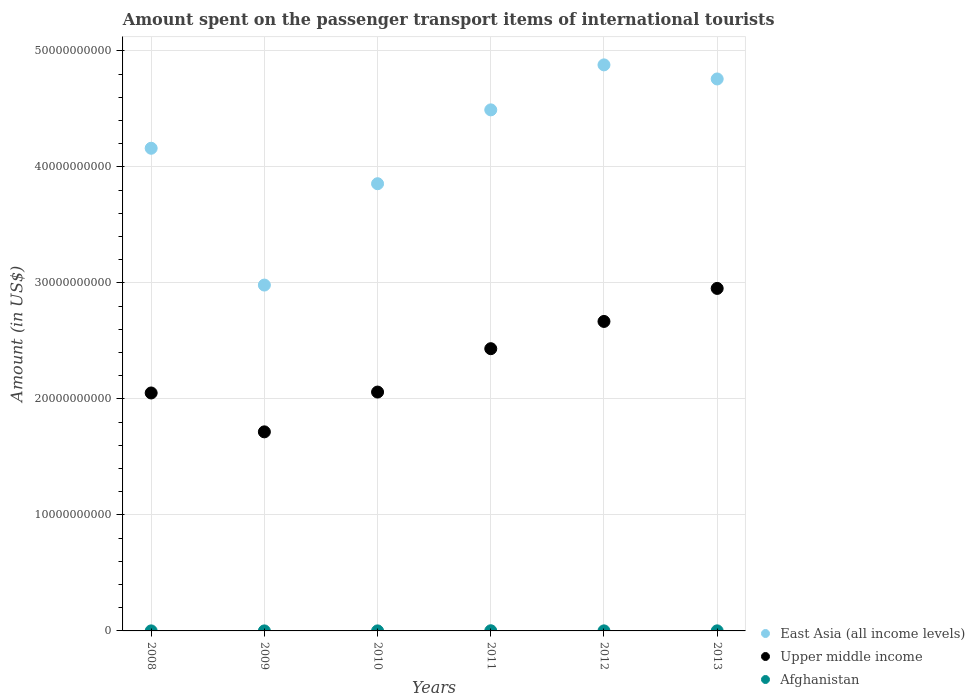How many different coloured dotlines are there?
Keep it short and to the point. 3. What is the amount spent on the passenger transport items of international tourists in Upper middle income in 2013?
Offer a terse response. 2.95e+1. Across all years, what is the maximum amount spent on the passenger transport items of international tourists in Afghanistan?
Ensure brevity in your answer.  1.40e+07. Across all years, what is the minimum amount spent on the passenger transport items of international tourists in Upper middle income?
Provide a short and direct response. 1.72e+1. What is the total amount spent on the passenger transport items of international tourists in Afghanistan in the graph?
Make the answer very short. 3.30e+07. What is the difference between the amount spent on the passenger transport items of international tourists in Afghanistan in 2011 and that in 2012?
Make the answer very short. 9.00e+06. What is the difference between the amount spent on the passenger transport items of international tourists in East Asia (all income levels) in 2011 and the amount spent on the passenger transport items of international tourists in Upper middle income in 2012?
Offer a terse response. 1.82e+1. What is the average amount spent on the passenger transport items of international tourists in Upper middle income per year?
Your answer should be compact. 2.31e+1. In the year 2011, what is the difference between the amount spent on the passenger transport items of international tourists in Afghanistan and amount spent on the passenger transport items of international tourists in Upper middle income?
Offer a terse response. -2.43e+1. In how many years, is the amount spent on the passenger transport items of international tourists in Afghanistan greater than 14000000000 US$?
Keep it short and to the point. 0. What is the ratio of the amount spent on the passenger transport items of international tourists in Afghanistan in 2012 to that in 2013?
Offer a very short reply. 0.83. Is the amount spent on the passenger transport items of international tourists in Afghanistan in 2008 less than that in 2010?
Your answer should be very brief. No. What is the difference between the highest and the lowest amount spent on the passenger transport items of international tourists in East Asia (all income levels)?
Your response must be concise. 1.90e+1. Is it the case that in every year, the sum of the amount spent on the passenger transport items of international tourists in Afghanistan and amount spent on the passenger transport items of international tourists in East Asia (all income levels)  is greater than the amount spent on the passenger transport items of international tourists in Upper middle income?
Your answer should be compact. Yes. Is the amount spent on the passenger transport items of international tourists in East Asia (all income levels) strictly less than the amount spent on the passenger transport items of international tourists in Afghanistan over the years?
Keep it short and to the point. No. How many dotlines are there?
Offer a very short reply. 3. What is the difference between two consecutive major ticks on the Y-axis?
Your response must be concise. 1.00e+1. Does the graph contain grids?
Keep it short and to the point. Yes. How are the legend labels stacked?
Offer a terse response. Vertical. What is the title of the graph?
Give a very brief answer. Amount spent on the passenger transport items of international tourists. What is the label or title of the X-axis?
Your answer should be compact. Years. What is the Amount (in US$) in East Asia (all income levels) in 2008?
Offer a terse response. 4.16e+1. What is the Amount (in US$) in Upper middle income in 2008?
Ensure brevity in your answer.  2.05e+1. What is the Amount (in US$) in Afghanistan in 2008?
Your answer should be compact. 3.00e+06. What is the Amount (in US$) of East Asia (all income levels) in 2009?
Your answer should be very brief. 2.98e+1. What is the Amount (in US$) in Upper middle income in 2009?
Ensure brevity in your answer.  1.72e+1. What is the Amount (in US$) of East Asia (all income levels) in 2010?
Your answer should be very brief. 3.86e+1. What is the Amount (in US$) of Upper middle income in 2010?
Your response must be concise. 2.06e+1. What is the Amount (in US$) of Afghanistan in 2010?
Provide a short and direct response. 3.00e+06. What is the Amount (in US$) of East Asia (all income levels) in 2011?
Provide a succinct answer. 4.49e+1. What is the Amount (in US$) in Upper middle income in 2011?
Give a very brief answer. 2.43e+1. What is the Amount (in US$) in Afghanistan in 2011?
Provide a succinct answer. 1.40e+07. What is the Amount (in US$) in East Asia (all income levels) in 2012?
Your answer should be compact. 4.88e+1. What is the Amount (in US$) of Upper middle income in 2012?
Make the answer very short. 2.67e+1. What is the Amount (in US$) in Afghanistan in 2012?
Offer a very short reply. 5.00e+06. What is the Amount (in US$) in East Asia (all income levels) in 2013?
Your answer should be compact. 4.76e+1. What is the Amount (in US$) in Upper middle income in 2013?
Provide a short and direct response. 2.95e+1. What is the Amount (in US$) in Afghanistan in 2013?
Provide a succinct answer. 6.00e+06. Across all years, what is the maximum Amount (in US$) of East Asia (all income levels)?
Keep it short and to the point. 4.88e+1. Across all years, what is the maximum Amount (in US$) in Upper middle income?
Provide a succinct answer. 2.95e+1. Across all years, what is the maximum Amount (in US$) of Afghanistan?
Your answer should be very brief. 1.40e+07. Across all years, what is the minimum Amount (in US$) in East Asia (all income levels)?
Offer a terse response. 2.98e+1. Across all years, what is the minimum Amount (in US$) in Upper middle income?
Offer a very short reply. 1.72e+1. What is the total Amount (in US$) of East Asia (all income levels) in the graph?
Your answer should be compact. 2.51e+11. What is the total Amount (in US$) in Upper middle income in the graph?
Keep it short and to the point. 1.39e+11. What is the total Amount (in US$) of Afghanistan in the graph?
Offer a terse response. 3.30e+07. What is the difference between the Amount (in US$) of East Asia (all income levels) in 2008 and that in 2009?
Make the answer very short. 1.18e+1. What is the difference between the Amount (in US$) in Upper middle income in 2008 and that in 2009?
Your answer should be compact. 3.35e+09. What is the difference between the Amount (in US$) in East Asia (all income levels) in 2008 and that in 2010?
Your answer should be compact. 3.06e+09. What is the difference between the Amount (in US$) of Upper middle income in 2008 and that in 2010?
Offer a terse response. -7.85e+07. What is the difference between the Amount (in US$) of Afghanistan in 2008 and that in 2010?
Offer a terse response. 0. What is the difference between the Amount (in US$) in East Asia (all income levels) in 2008 and that in 2011?
Provide a short and direct response. -3.31e+09. What is the difference between the Amount (in US$) of Upper middle income in 2008 and that in 2011?
Your answer should be very brief. -3.82e+09. What is the difference between the Amount (in US$) in Afghanistan in 2008 and that in 2011?
Offer a very short reply. -1.10e+07. What is the difference between the Amount (in US$) in East Asia (all income levels) in 2008 and that in 2012?
Your answer should be very brief. -7.19e+09. What is the difference between the Amount (in US$) in Upper middle income in 2008 and that in 2012?
Keep it short and to the point. -6.17e+09. What is the difference between the Amount (in US$) in Afghanistan in 2008 and that in 2012?
Provide a succinct answer. -2.00e+06. What is the difference between the Amount (in US$) of East Asia (all income levels) in 2008 and that in 2013?
Make the answer very short. -5.97e+09. What is the difference between the Amount (in US$) of Upper middle income in 2008 and that in 2013?
Your answer should be very brief. -9.01e+09. What is the difference between the Amount (in US$) in East Asia (all income levels) in 2009 and that in 2010?
Provide a short and direct response. -8.74e+09. What is the difference between the Amount (in US$) of Upper middle income in 2009 and that in 2010?
Keep it short and to the point. -3.43e+09. What is the difference between the Amount (in US$) in Afghanistan in 2009 and that in 2010?
Provide a short and direct response. -1.00e+06. What is the difference between the Amount (in US$) of East Asia (all income levels) in 2009 and that in 2011?
Give a very brief answer. -1.51e+1. What is the difference between the Amount (in US$) in Upper middle income in 2009 and that in 2011?
Ensure brevity in your answer.  -7.17e+09. What is the difference between the Amount (in US$) in Afghanistan in 2009 and that in 2011?
Give a very brief answer. -1.20e+07. What is the difference between the Amount (in US$) of East Asia (all income levels) in 2009 and that in 2012?
Give a very brief answer. -1.90e+1. What is the difference between the Amount (in US$) of Upper middle income in 2009 and that in 2012?
Ensure brevity in your answer.  -9.52e+09. What is the difference between the Amount (in US$) in East Asia (all income levels) in 2009 and that in 2013?
Offer a very short reply. -1.78e+1. What is the difference between the Amount (in US$) in Upper middle income in 2009 and that in 2013?
Keep it short and to the point. -1.24e+1. What is the difference between the Amount (in US$) in East Asia (all income levels) in 2010 and that in 2011?
Offer a very short reply. -6.37e+09. What is the difference between the Amount (in US$) of Upper middle income in 2010 and that in 2011?
Your response must be concise. -3.74e+09. What is the difference between the Amount (in US$) in Afghanistan in 2010 and that in 2011?
Provide a short and direct response. -1.10e+07. What is the difference between the Amount (in US$) of East Asia (all income levels) in 2010 and that in 2012?
Keep it short and to the point. -1.02e+1. What is the difference between the Amount (in US$) in Upper middle income in 2010 and that in 2012?
Make the answer very short. -6.09e+09. What is the difference between the Amount (in US$) of East Asia (all income levels) in 2010 and that in 2013?
Give a very brief answer. -9.03e+09. What is the difference between the Amount (in US$) of Upper middle income in 2010 and that in 2013?
Offer a terse response. -8.94e+09. What is the difference between the Amount (in US$) of East Asia (all income levels) in 2011 and that in 2012?
Provide a short and direct response. -3.88e+09. What is the difference between the Amount (in US$) of Upper middle income in 2011 and that in 2012?
Provide a succinct answer. -2.35e+09. What is the difference between the Amount (in US$) of Afghanistan in 2011 and that in 2012?
Provide a succinct answer. 9.00e+06. What is the difference between the Amount (in US$) in East Asia (all income levels) in 2011 and that in 2013?
Your response must be concise. -2.66e+09. What is the difference between the Amount (in US$) in Upper middle income in 2011 and that in 2013?
Your answer should be very brief. -5.20e+09. What is the difference between the Amount (in US$) of Afghanistan in 2011 and that in 2013?
Ensure brevity in your answer.  8.00e+06. What is the difference between the Amount (in US$) in East Asia (all income levels) in 2012 and that in 2013?
Offer a terse response. 1.21e+09. What is the difference between the Amount (in US$) in Upper middle income in 2012 and that in 2013?
Make the answer very short. -2.85e+09. What is the difference between the Amount (in US$) of Afghanistan in 2012 and that in 2013?
Provide a short and direct response. -1.00e+06. What is the difference between the Amount (in US$) in East Asia (all income levels) in 2008 and the Amount (in US$) in Upper middle income in 2009?
Make the answer very short. 2.45e+1. What is the difference between the Amount (in US$) in East Asia (all income levels) in 2008 and the Amount (in US$) in Afghanistan in 2009?
Your answer should be compact. 4.16e+1. What is the difference between the Amount (in US$) of Upper middle income in 2008 and the Amount (in US$) of Afghanistan in 2009?
Your response must be concise. 2.05e+1. What is the difference between the Amount (in US$) of East Asia (all income levels) in 2008 and the Amount (in US$) of Upper middle income in 2010?
Make the answer very short. 2.10e+1. What is the difference between the Amount (in US$) in East Asia (all income levels) in 2008 and the Amount (in US$) in Afghanistan in 2010?
Make the answer very short. 4.16e+1. What is the difference between the Amount (in US$) in Upper middle income in 2008 and the Amount (in US$) in Afghanistan in 2010?
Your response must be concise. 2.05e+1. What is the difference between the Amount (in US$) of East Asia (all income levels) in 2008 and the Amount (in US$) of Upper middle income in 2011?
Your answer should be compact. 1.73e+1. What is the difference between the Amount (in US$) of East Asia (all income levels) in 2008 and the Amount (in US$) of Afghanistan in 2011?
Provide a short and direct response. 4.16e+1. What is the difference between the Amount (in US$) in Upper middle income in 2008 and the Amount (in US$) in Afghanistan in 2011?
Give a very brief answer. 2.05e+1. What is the difference between the Amount (in US$) in East Asia (all income levels) in 2008 and the Amount (in US$) in Upper middle income in 2012?
Make the answer very short. 1.49e+1. What is the difference between the Amount (in US$) of East Asia (all income levels) in 2008 and the Amount (in US$) of Afghanistan in 2012?
Your response must be concise. 4.16e+1. What is the difference between the Amount (in US$) in Upper middle income in 2008 and the Amount (in US$) in Afghanistan in 2012?
Your answer should be very brief. 2.05e+1. What is the difference between the Amount (in US$) in East Asia (all income levels) in 2008 and the Amount (in US$) in Upper middle income in 2013?
Ensure brevity in your answer.  1.21e+1. What is the difference between the Amount (in US$) in East Asia (all income levels) in 2008 and the Amount (in US$) in Afghanistan in 2013?
Ensure brevity in your answer.  4.16e+1. What is the difference between the Amount (in US$) in Upper middle income in 2008 and the Amount (in US$) in Afghanistan in 2013?
Offer a very short reply. 2.05e+1. What is the difference between the Amount (in US$) of East Asia (all income levels) in 2009 and the Amount (in US$) of Upper middle income in 2010?
Ensure brevity in your answer.  9.22e+09. What is the difference between the Amount (in US$) of East Asia (all income levels) in 2009 and the Amount (in US$) of Afghanistan in 2010?
Make the answer very short. 2.98e+1. What is the difference between the Amount (in US$) of Upper middle income in 2009 and the Amount (in US$) of Afghanistan in 2010?
Keep it short and to the point. 1.72e+1. What is the difference between the Amount (in US$) in East Asia (all income levels) in 2009 and the Amount (in US$) in Upper middle income in 2011?
Offer a terse response. 5.49e+09. What is the difference between the Amount (in US$) in East Asia (all income levels) in 2009 and the Amount (in US$) in Afghanistan in 2011?
Offer a terse response. 2.98e+1. What is the difference between the Amount (in US$) in Upper middle income in 2009 and the Amount (in US$) in Afghanistan in 2011?
Your answer should be very brief. 1.71e+1. What is the difference between the Amount (in US$) of East Asia (all income levels) in 2009 and the Amount (in US$) of Upper middle income in 2012?
Offer a terse response. 3.14e+09. What is the difference between the Amount (in US$) of East Asia (all income levels) in 2009 and the Amount (in US$) of Afghanistan in 2012?
Keep it short and to the point. 2.98e+1. What is the difference between the Amount (in US$) in Upper middle income in 2009 and the Amount (in US$) in Afghanistan in 2012?
Ensure brevity in your answer.  1.72e+1. What is the difference between the Amount (in US$) of East Asia (all income levels) in 2009 and the Amount (in US$) of Upper middle income in 2013?
Your answer should be very brief. 2.89e+08. What is the difference between the Amount (in US$) in East Asia (all income levels) in 2009 and the Amount (in US$) in Afghanistan in 2013?
Your answer should be very brief. 2.98e+1. What is the difference between the Amount (in US$) of Upper middle income in 2009 and the Amount (in US$) of Afghanistan in 2013?
Offer a very short reply. 1.72e+1. What is the difference between the Amount (in US$) in East Asia (all income levels) in 2010 and the Amount (in US$) in Upper middle income in 2011?
Your answer should be very brief. 1.42e+1. What is the difference between the Amount (in US$) in East Asia (all income levels) in 2010 and the Amount (in US$) in Afghanistan in 2011?
Your answer should be compact. 3.85e+1. What is the difference between the Amount (in US$) of Upper middle income in 2010 and the Amount (in US$) of Afghanistan in 2011?
Ensure brevity in your answer.  2.06e+1. What is the difference between the Amount (in US$) of East Asia (all income levels) in 2010 and the Amount (in US$) of Upper middle income in 2012?
Your answer should be very brief. 1.19e+1. What is the difference between the Amount (in US$) in East Asia (all income levels) in 2010 and the Amount (in US$) in Afghanistan in 2012?
Your answer should be compact. 3.86e+1. What is the difference between the Amount (in US$) of Upper middle income in 2010 and the Amount (in US$) of Afghanistan in 2012?
Make the answer very short. 2.06e+1. What is the difference between the Amount (in US$) of East Asia (all income levels) in 2010 and the Amount (in US$) of Upper middle income in 2013?
Make the answer very short. 9.03e+09. What is the difference between the Amount (in US$) in East Asia (all income levels) in 2010 and the Amount (in US$) in Afghanistan in 2013?
Offer a very short reply. 3.85e+1. What is the difference between the Amount (in US$) of Upper middle income in 2010 and the Amount (in US$) of Afghanistan in 2013?
Ensure brevity in your answer.  2.06e+1. What is the difference between the Amount (in US$) in East Asia (all income levels) in 2011 and the Amount (in US$) in Upper middle income in 2012?
Keep it short and to the point. 1.82e+1. What is the difference between the Amount (in US$) in East Asia (all income levels) in 2011 and the Amount (in US$) in Afghanistan in 2012?
Make the answer very short. 4.49e+1. What is the difference between the Amount (in US$) of Upper middle income in 2011 and the Amount (in US$) of Afghanistan in 2012?
Provide a short and direct response. 2.43e+1. What is the difference between the Amount (in US$) in East Asia (all income levels) in 2011 and the Amount (in US$) in Upper middle income in 2013?
Ensure brevity in your answer.  1.54e+1. What is the difference between the Amount (in US$) in East Asia (all income levels) in 2011 and the Amount (in US$) in Afghanistan in 2013?
Your answer should be compact. 4.49e+1. What is the difference between the Amount (in US$) in Upper middle income in 2011 and the Amount (in US$) in Afghanistan in 2013?
Your response must be concise. 2.43e+1. What is the difference between the Amount (in US$) in East Asia (all income levels) in 2012 and the Amount (in US$) in Upper middle income in 2013?
Keep it short and to the point. 1.93e+1. What is the difference between the Amount (in US$) of East Asia (all income levels) in 2012 and the Amount (in US$) of Afghanistan in 2013?
Your answer should be very brief. 4.88e+1. What is the difference between the Amount (in US$) in Upper middle income in 2012 and the Amount (in US$) in Afghanistan in 2013?
Your answer should be compact. 2.67e+1. What is the average Amount (in US$) in East Asia (all income levels) per year?
Provide a short and direct response. 4.19e+1. What is the average Amount (in US$) of Upper middle income per year?
Keep it short and to the point. 2.31e+1. What is the average Amount (in US$) of Afghanistan per year?
Your answer should be compact. 5.50e+06. In the year 2008, what is the difference between the Amount (in US$) of East Asia (all income levels) and Amount (in US$) of Upper middle income?
Your response must be concise. 2.11e+1. In the year 2008, what is the difference between the Amount (in US$) in East Asia (all income levels) and Amount (in US$) in Afghanistan?
Keep it short and to the point. 4.16e+1. In the year 2008, what is the difference between the Amount (in US$) of Upper middle income and Amount (in US$) of Afghanistan?
Give a very brief answer. 2.05e+1. In the year 2009, what is the difference between the Amount (in US$) in East Asia (all income levels) and Amount (in US$) in Upper middle income?
Provide a succinct answer. 1.27e+1. In the year 2009, what is the difference between the Amount (in US$) of East Asia (all income levels) and Amount (in US$) of Afghanistan?
Provide a succinct answer. 2.98e+1. In the year 2009, what is the difference between the Amount (in US$) in Upper middle income and Amount (in US$) in Afghanistan?
Keep it short and to the point. 1.72e+1. In the year 2010, what is the difference between the Amount (in US$) of East Asia (all income levels) and Amount (in US$) of Upper middle income?
Provide a succinct answer. 1.80e+1. In the year 2010, what is the difference between the Amount (in US$) in East Asia (all income levels) and Amount (in US$) in Afghanistan?
Make the answer very short. 3.86e+1. In the year 2010, what is the difference between the Amount (in US$) in Upper middle income and Amount (in US$) in Afghanistan?
Provide a short and direct response. 2.06e+1. In the year 2011, what is the difference between the Amount (in US$) in East Asia (all income levels) and Amount (in US$) in Upper middle income?
Offer a very short reply. 2.06e+1. In the year 2011, what is the difference between the Amount (in US$) of East Asia (all income levels) and Amount (in US$) of Afghanistan?
Keep it short and to the point. 4.49e+1. In the year 2011, what is the difference between the Amount (in US$) of Upper middle income and Amount (in US$) of Afghanistan?
Provide a succinct answer. 2.43e+1. In the year 2012, what is the difference between the Amount (in US$) of East Asia (all income levels) and Amount (in US$) of Upper middle income?
Offer a terse response. 2.21e+1. In the year 2012, what is the difference between the Amount (in US$) of East Asia (all income levels) and Amount (in US$) of Afghanistan?
Provide a short and direct response. 4.88e+1. In the year 2012, what is the difference between the Amount (in US$) of Upper middle income and Amount (in US$) of Afghanistan?
Give a very brief answer. 2.67e+1. In the year 2013, what is the difference between the Amount (in US$) in East Asia (all income levels) and Amount (in US$) in Upper middle income?
Your answer should be very brief. 1.81e+1. In the year 2013, what is the difference between the Amount (in US$) in East Asia (all income levels) and Amount (in US$) in Afghanistan?
Your answer should be compact. 4.76e+1. In the year 2013, what is the difference between the Amount (in US$) in Upper middle income and Amount (in US$) in Afghanistan?
Your answer should be compact. 2.95e+1. What is the ratio of the Amount (in US$) in East Asia (all income levels) in 2008 to that in 2009?
Keep it short and to the point. 1.4. What is the ratio of the Amount (in US$) of Upper middle income in 2008 to that in 2009?
Give a very brief answer. 1.2. What is the ratio of the Amount (in US$) of Afghanistan in 2008 to that in 2009?
Make the answer very short. 1.5. What is the ratio of the Amount (in US$) of East Asia (all income levels) in 2008 to that in 2010?
Your answer should be compact. 1.08. What is the ratio of the Amount (in US$) in East Asia (all income levels) in 2008 to that in 2011?
Offer a terse response. 0.93. What is the ratio of the Amount (in US$) of Upper middle income in 2008 to that in 2011?
Your response must be concise. 0.84. What is the ratio of the Amount (in US$) in Afghanistan in 2008 to that in 2011?
Offer a very short reply. 0.21. What is the ratio of the Amount (in US$) of East Asia (all income levels) in 2008 to that in 2012?
Your response must be concise. 0.85. What is the ratio of the Amount (in US$) in Upper middle income in 2008 to that in 2012?
Offer a terse response. 0.77. What is the ratio of the Amount (in US$) of Afghanistan in 2008 to that in 2012?
Make the answer very short. 0.6. What is the ratio of the Amount (in US$) of East Asia (all income levels) in 2008 to that in 2013?
Your response must be concise. 0.87. What is the ratio of the Amount (in US$) in Upper middle income in 2008 to that in 2013?
Keep it short and to the point. 0.69. What is the ratio of the Amount (in US$) of Afghanistan in 2008 to that in 2013?
Your answer should be compact. 0.5. What is the ratio of the Amount (in US$) in East Asia (all income levels) in 2009 to that in 2010?
Make the answer very short. 0.77. What is the ratio of the Amount (in US$) in Upper middle income in 2009 to that in 2010?
Offer a terse response. 0.83. What is the ratio of the Amount (in US$) in East Asia (all income levels) in 2009 to that in 2011?
Your answer should be compact. 0.66. What is the ratio of the Amount (in US$) of Upper middle income in 2009 to that in 2011?
Make the answer very short. 0.71. What is the ratio of the Amount (in US$) in Afghanistan in 2009 to that in 2011?
Offer a very short reply. 0.14. What is the ratio of the Amount (in US$) of East Asia (all income levels) in 2009 to that in 2012?
Your response must be concise. 0.61. What is the ratio of the Amount (in US$) of Upper middle income in 2009 to that in 2012?
Offer a terse response. 0.64. What is the ratio of the Amount (in US$) in Afghanistan in 2009 to that in 2012?
Your response must be concise. 0.4. What is the ratio of the Amount (in US$) in East Asia (all income levels) in 2009 to that in 2013?
Keep it short and to the point. 0.63. What is the ratio of the Amount (in US$) of Upper middle income in 2009 to that in 2013?
Provide a short and direct response. 0.58. What is the ratio of the Amount (in US$) of East Asia (all income levels) in 2010 to that in 2011?
Provide a short and direct response. 0.86. What is the ratio of the Amount (in US$) in Upper middle income in 2010 to that in 2011?
Keep it short and to the point. 0.85. What is the ratio of the Amount (in US$) in Afghanistan in 2010 to that in 2011?
Keep it short and to the point. 0.21. What is the ratio of the Amount (in US$) of East Asia (all income levels) in 2010 to that in 2012?
Keep it short and to the point. 0.79. What is the ratio of the Amount (in US$) in Upper middle income in 2010 to that in 2012?
Ensure brevity in your answer.  0.77. What is the ratio of the Amount (in US$) in Afghanistan in 2010 to that in 2012?
Keep it short and to the point. 0.6. What is the ratio of the Amount (in US$) in East Asia (all income levels) in 2010 to that in 2013?
Provide a succinct answer. 0.81. What is the ratio of the Amount (in US$) of Upper middle income in 2010 to that in 2013?
Give a very brief answer. 0.7. What is the ratio of the Amount (in US$) in East Asia (all income levels) in 2011 to that in 2012?
Provide a succinct answer. 0.92. What is the ratio of the Amount (in US$) in Upper middle income in 2011 to that in 2012?
Provide a succinct answer. 0.91. What is the ratio of the Amount (in US$) of East Asia (all income levels) in 2011 to that in 2013?
Make the answer very short. 0.94. What is the ratio of the Amount (in US$) of Upper middle income in 2011 to that in 2013?
Ensure brevity in your answer.  0.82. What is the ratio of the Amount (in US$) of Afghanistan in 2011 to that in 2013?
Provide a short and direct response. 2.33. What is the ratio of the Amount (in US$) in East Asia (all income levels) in 2012 to that in 2013?
Ensure brevity in your answer.  1.03. What is the ratio of the Amount (in US$) of Upper middle income in 2012 to that in 2013?
Provide a short and direct response. 0.9. What is the difference between the highest and the second highest Amount (in US$) in East Asia (all income levels)?
Ensure brevity in your answer.  1.21e+09. What is the difference between the highest and the second highest Amount (in US$) of Upper middle income?
Your answer should be very brief. 2.85e+09. What is the difference between the highest and the second highest Amount (in US$) of Afghanistan?
Your answer should be compact. 8.00e+06. What is the difference between the highest and the lowest Amount (in US$) in East Asia (all income levels)?
Offer a very short reply. 1.90e+1. What is the difference between the highest and the lowest Amount (in US$) of Upper middle income?
Your answer should be compact. 1.24e+1. 